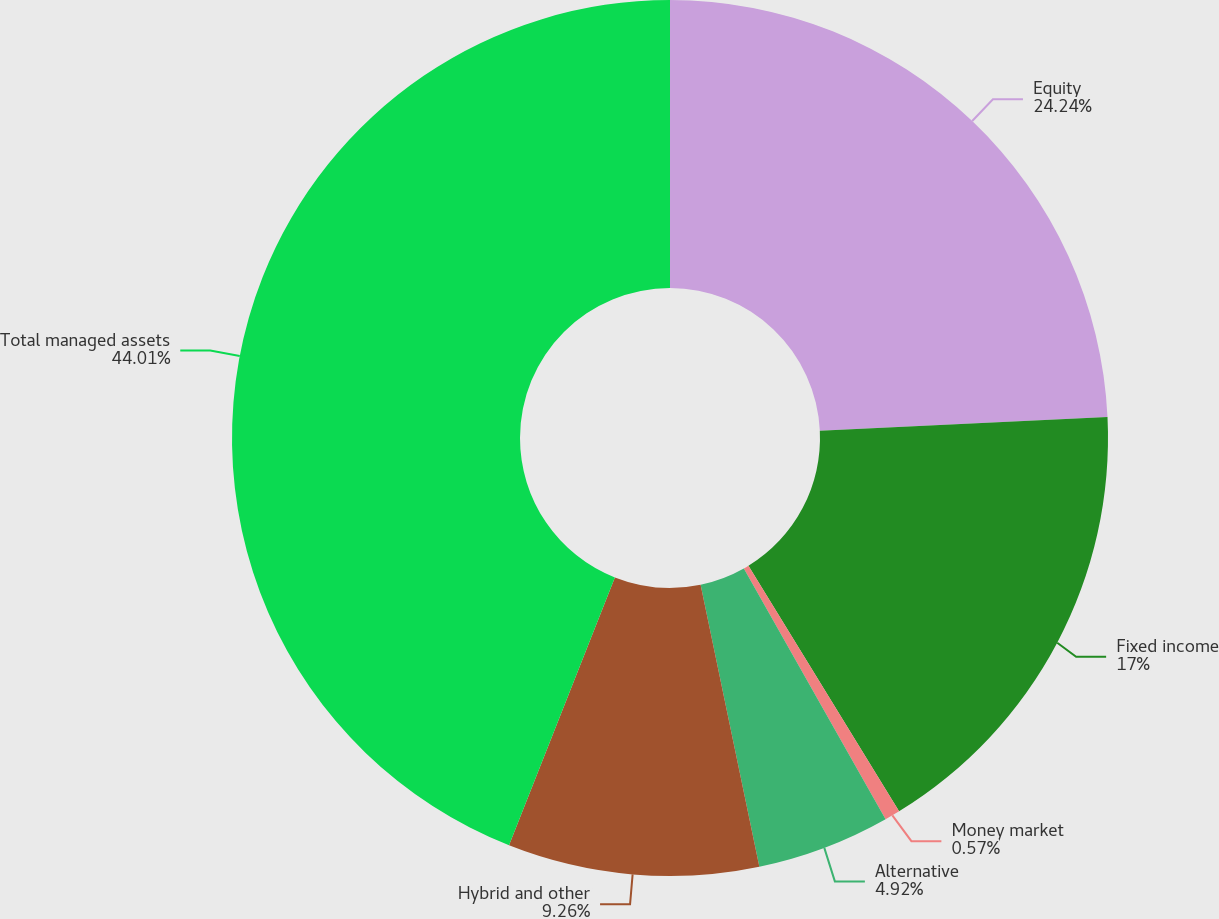<chart> <loc_0><loc_0><loc_500><loc_500><pie_chart><fcel>Equity<fcel>Fixed income<fcel>Money market<fcel>Alternative<fcel>Hybrid and other<fcel>Total managed assets<nl><fcel>24.24%<fcel>17.0%<fcel>0.57%<fcel>4.92%<fcel>9.26%<fcel>44.01%<nl></chart> 